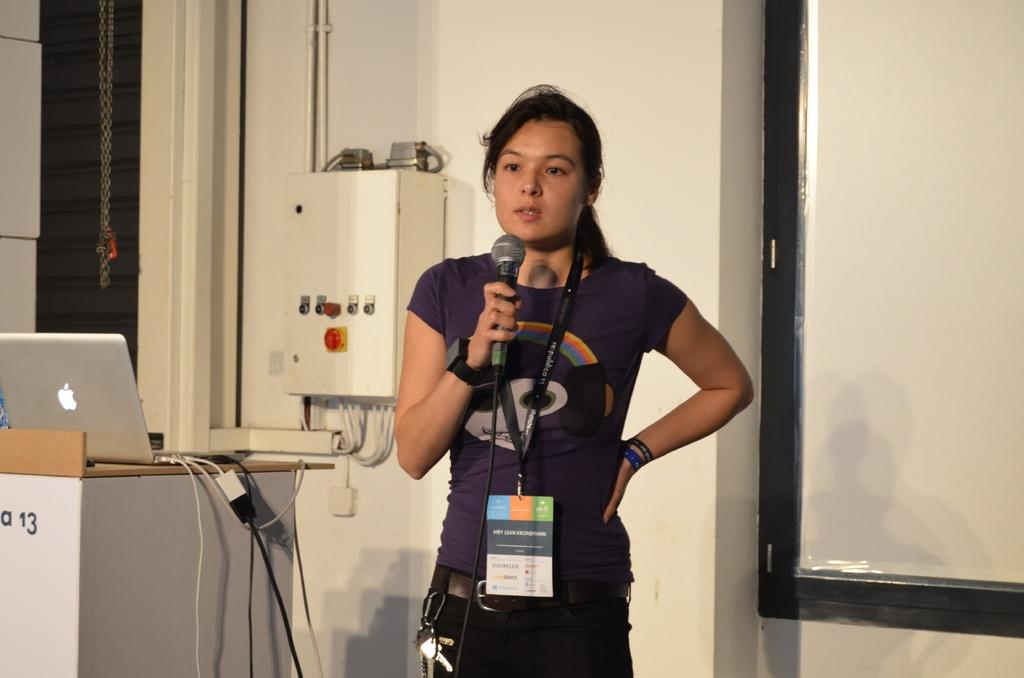Who is the main subject in the image? There is a woman in the image. What is the woman holding in her hand? The woman is holding a mic in her hand. What is the woman doing in the image? The woman is talking. What is on the podium in the image? A laptop is present on the podium. What can be seen in the background of the image? There is a wall, a box, a pipe, and a screen in the background of the image. What type of vacation is the woman planning based on the image? There is no information about a vacation in the image. What word is the woman saying into the mic? The image does not provide any information about the specific words the woman is saying. 